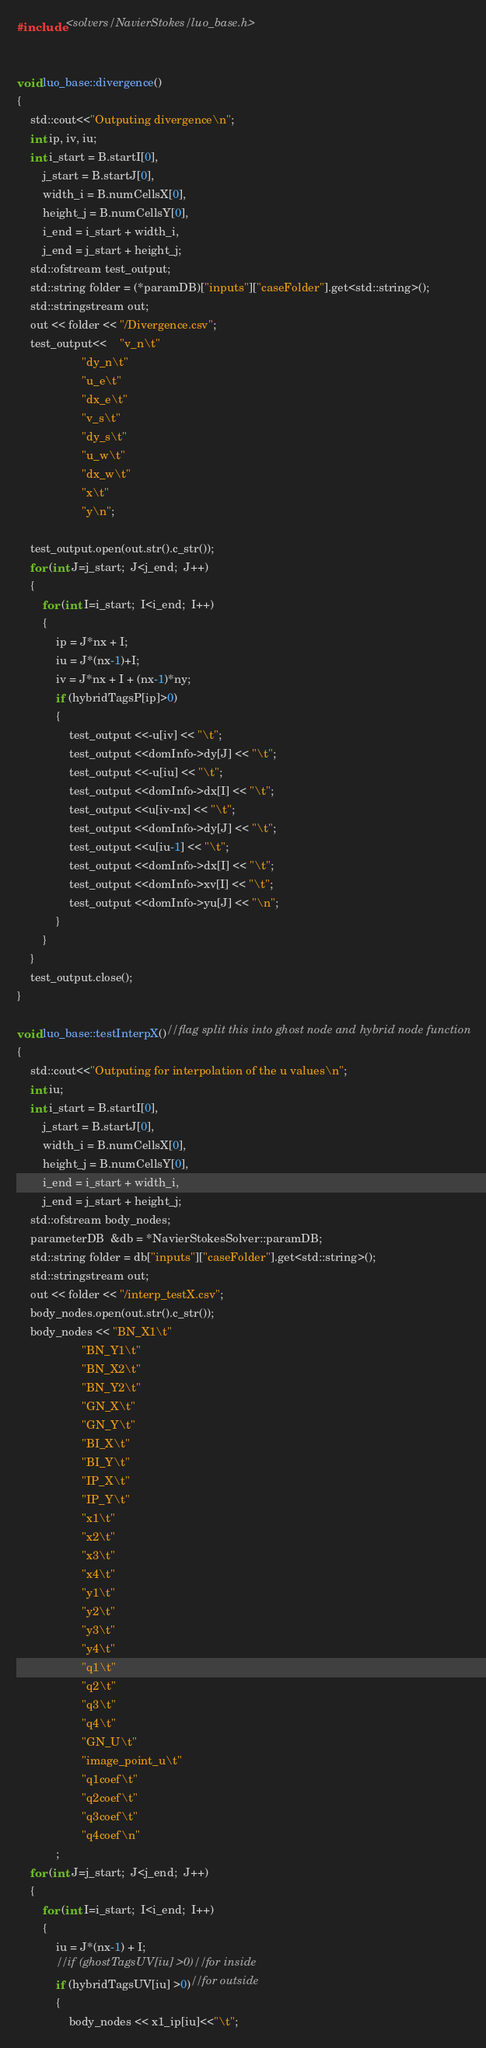<code> <loc_0><loc_0><loc_500><loc_500><_Cuda_>#include <solvers/NavierStokes/luo_base.h>


void luo_base::divergence()
{
	std::cout<<"Outputing divergence\n";
	int ip, iv, iu;
	int i_start = B.startI[0],
		j_start = B.startJ[0],
		width_i = B.numCellsX[0],
		height_j = B.numCellsY[0],
		i_end = i_start + width_i,
		j_end = j_start + height_j;
	std::ofstream test_output;
	std::string folder = (*paramDB)["inputs"]["caseFolder"].get<std::string>();
	std::stringstream out;
	out << folder << "/Divergence.csv";
	test_output<<	"v_n\t"
					"dy_n\t"
					"u_e\t"
					"dx_e\t"
					"v_s\t"
					"dy_s\t"
					"u_w\t"
					"dx_w\t"
					"x\t"
					"y\n";

	test_output.open(out.str().c_str());
	for (int J=j_start;  J<j_end;  J++)
	{
		for (int I=i_start;  I<i_end;  I++)
		{
			ip = J*nx + I;
			iu = J*(nx-1)+I;
			iv = J*nx + I + (nx-1)*ny;
			if (hybridTagsP[ip]>0)
			{
				test_output <<-u[iv] << "\t";
				test_output <<domInfo->dy[J] << "\t";
				test_output <<-u[iu] << "\t";
				test_output <<domInfo->dx[I] << "\t";
				test_output <<u[iv-nx] << "\t";
				test_output <<domInfo->dy[J] << "\t";
				test_output <<u[iu-1] << "\t";
				test_output <<domInfo->dx[I] << "\t";
				test_output <<domInfo->xv[I] << "\t";
				test_output <<domInfo->yu[J] << "\n";
			}
		}
	}
	test_output.close();
}

void luo_base::testInterpX()//flag split this into ghost node and hybrid node function
{
	std::cout<<"Outputing for interpolation of the u values\n";
	int iu;
	int i_start = B.startI[0],
		j_start = B.startJ[0],
		width_i = B.numCellsX[0],
		height_j = B.numCellsY[0],
		i_end = i_start + width_i,
		j_end = j_start + height_j;
	std::ofstream body_nodes;
	parameterDB  &db = *NavierStokesSolver::paramDB;
	std::string folder = db["inputs"]["caseFolder"].get<std::string>();
	std::stringstream out;
	out << folder << "/interp_testX.csv";
	body_nodes.open(out.str().c_str());
	body_nodes << "BN_X1\t"
					"BN_Y1\t"
					"BN_X2\t"
					"BN_Y2\t"
					"GN_X\t"
					"GN_Y\t"
					"BI_X\t"
					"BI_Y\t"
					"IP_X\t"
					"IP_Y\t"
					"x1\t"
					"x2\t"
					"x3\t"
					"x4\t"
					"y1\t"
					"y2\t"
					"y3\t"
					"y4\t"
					"q1\t"
					"q2\t"
					"q3\t"
					"q4\t"
					"GN_U\t"
					"image_point_u\t"
					"q1coef\t"
					"q2coef\t"
					"q3coef\t"
					"q4coef\n"
			;
	for (int J=j_start;  J<j_end;  J++)
	{
		for (int I=i_start;  I<i_end;  I++)
		{
			iu = J*(nx-1) + I;
			//if (ghostTagsUV[iu] >0)//for inside
			if (hybridTagsUV[iu] >0)//for outside
			{
				body_nodes << x1_ip[iu]<<"\t";</code> 